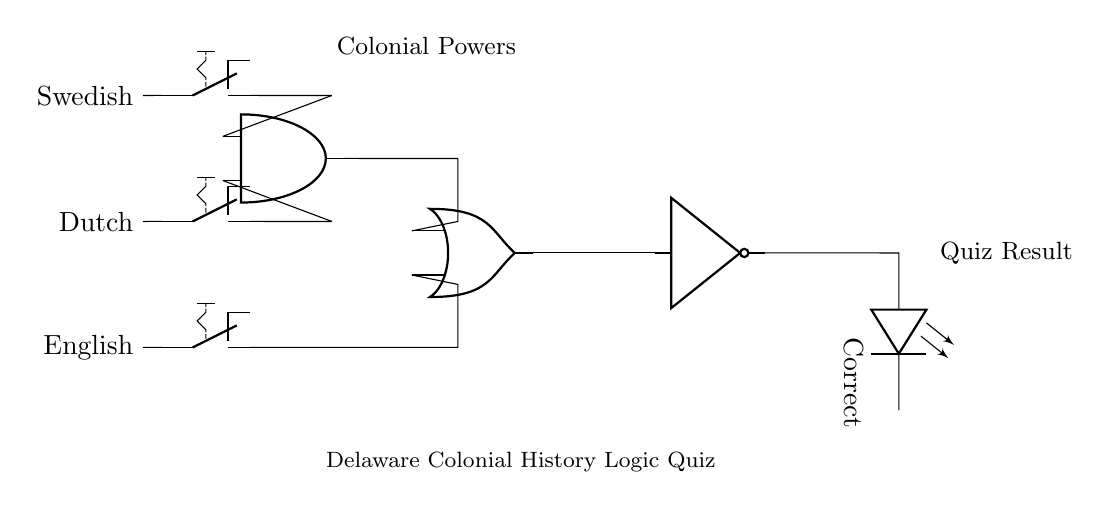What are the three colonial powers represented as inputs in the circuit? The input switches represent the Swedish, Dutch, and English colonial powers as specified on the left side of the circuit diagram.
Answer: Swedish, Dutch, English What logic gate combines the Swedish and Dutch inputs? The logical operation performed on the Swedish and Dutch inputs is handled by the AND gate, which outputs true only if both inputs are true.
Answer: AND gate What is the final type of logic gate used in the circuit? The final logic gate in the circuit is a NOT gate, which inverts the output coming from the OR gate.
Answer: NOT gate What condition must be met for the LED labeled 'Correct' to light up? The LED will light up when neither the English power is present nor both the Swedish and Dutch powers are together since the NOT gate inverts the output of the OR gate.
Answer: Neither English nor (Swedish AND Dutch) How many total gates are in the circuit? The circuit contains three gates: one AND gate, one OR gate, and one NOT gate, summing up to a total of three logical gates.
Answer: Three What logical operation does the OR gate perform with English input and the output of the AND gate? The OR gate outputs true if either the English input is true or the output from the AND gate (Swedish AND Dutch) is true, allowing for more than one path to a true result.
Answer: OR operation 